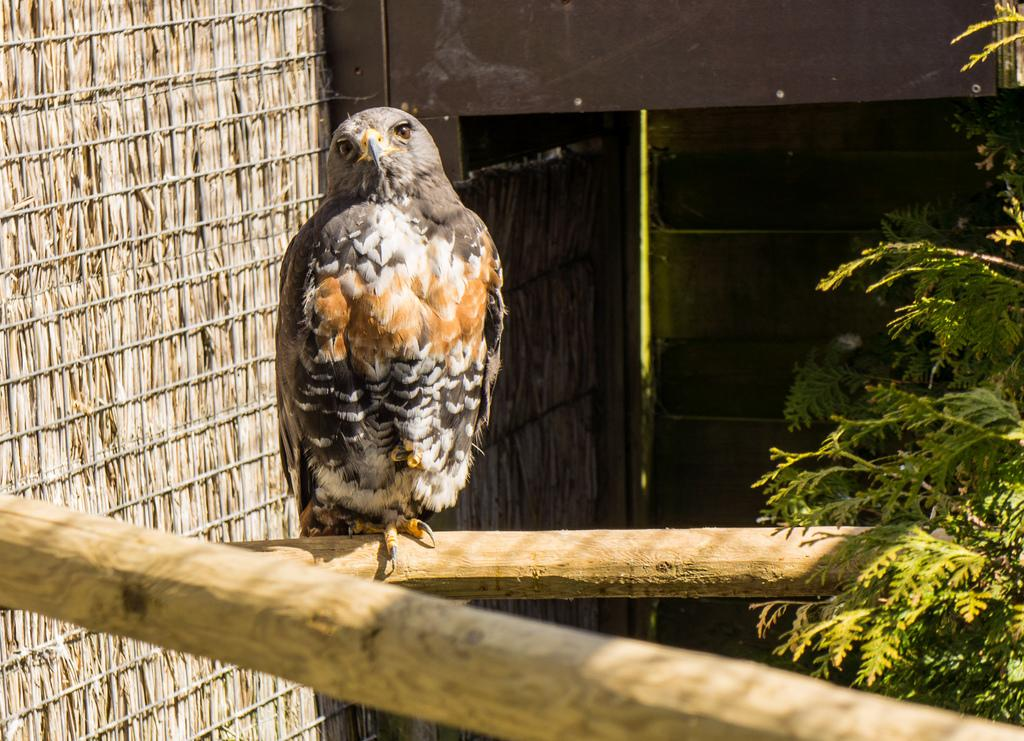What type of animal is in the image? There is an owl in the image. Where is the owl located? The owl is on a branch. What part of the owl is visible in the image? The owl has eyes. What is the owl sitting on in the image? The owl is on a branch of a tree. What type of art can be seen hanging on the tree in the image? There is no art hanging on the tree in the image; it only features an owl on a branch. 